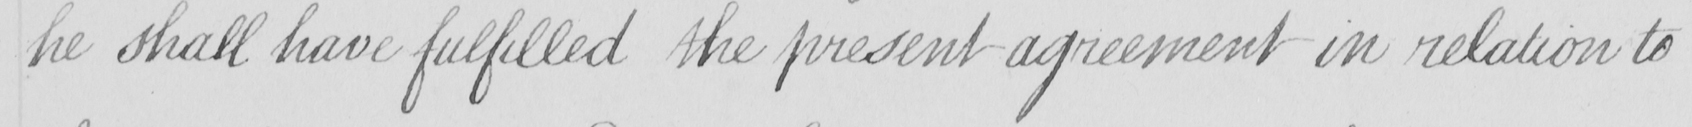Can you read and transcribe this handwriting? he shall have fulfilled the present agreement in relation to 